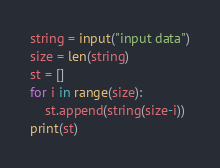<code> <loc_0><loc_0><loc_500><loc_500><_Python_>string = input("input data")
size = len(string)
st = []
for i in range(size):
    st.append(string(size-i))
print(st)
</code> 